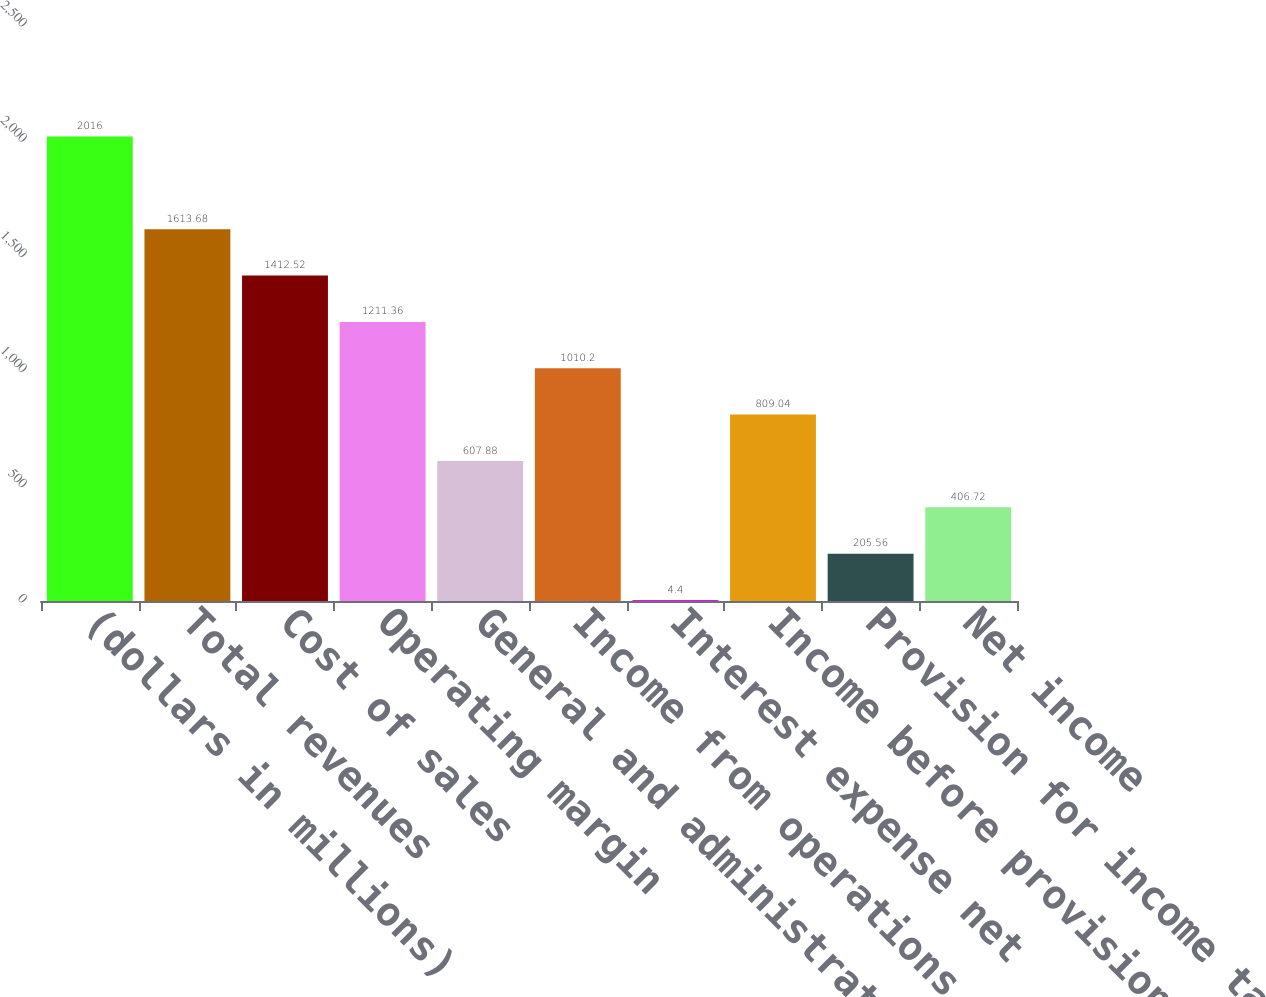Convert chart to OTSL. <chart><loc_0><loc_0><loc_500><loc_500><bar_chart><fcel>(dollars in millions)<fcel>Total revenues<fcel>Cost of sales<fcel>Operating margin<fcel>General and administrative<fcel>Income from operations<fcel>Interest expense net<fcel>Income before provision for<fcel>Provision for income taxes<fcel>Net income<nl><fcel>2016<fcel>1613.68<fcel>1412.52<fcel>1211.36<fcel>607.88<fcel>1010.2<fcel>4.4<fcel>809.04<fcel>205.56<fcel>406.72<nl></chart> 